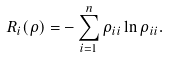Convert formula to latex. <formula><loc_0><loc_0><loc_500><loc_500>R _ { i } ( \rho ) = - \sum _ { i = 1 } ^ { n } \rho _ { i i } \ln \rho _ { i i } .</formula> 